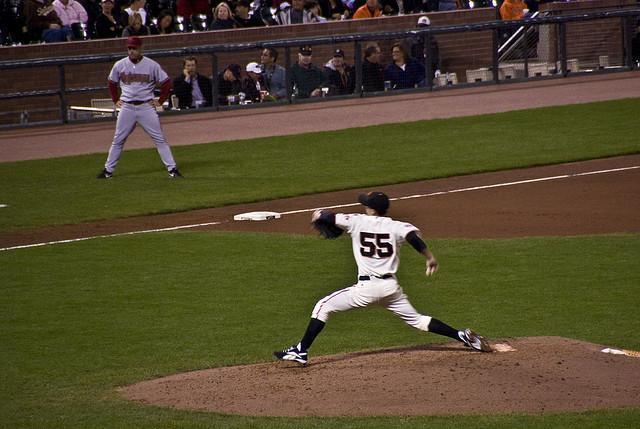How many people are visible?
Give a very brief answer. 3. How many clocks are visible?
Give a very brief answer. 0. 